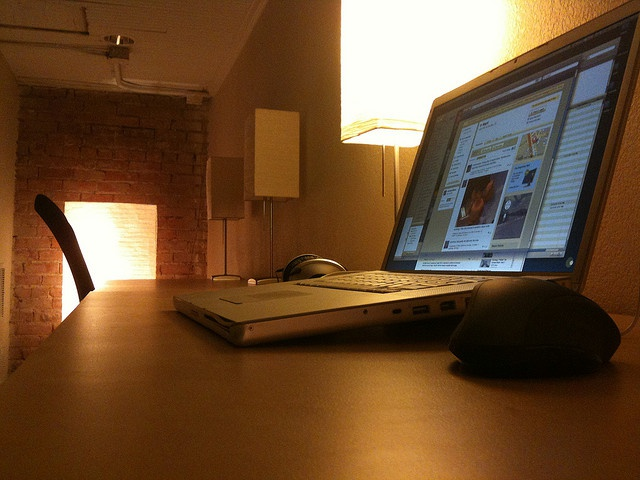Describe the objects in this image and their specific colors. I can see laptop in maroon, black, and gray tones, mouse in maroon, black, and brown tones, and chair in maroon, black, darkgray, and lightgray tones in this image. 